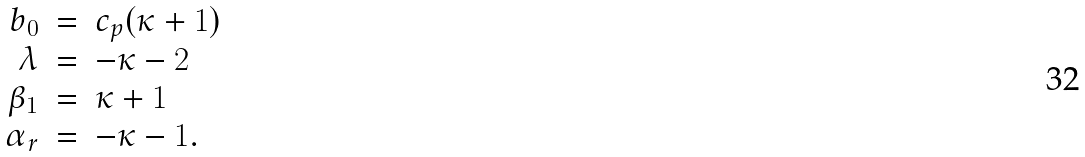<formula> <loc_0><loc_0><loc_500><loc_500>\begin{array} { r c l } b _ { 0 } & = & c _ { p } ( \kappa + 1 ) \\ \lambda & = & - \kappa - 2 \\ \beta _ { 1 } & = & \kappa + 1 \\ \alpha _ { r } & = & - \kappa - 1 . \end{array}</formula> 